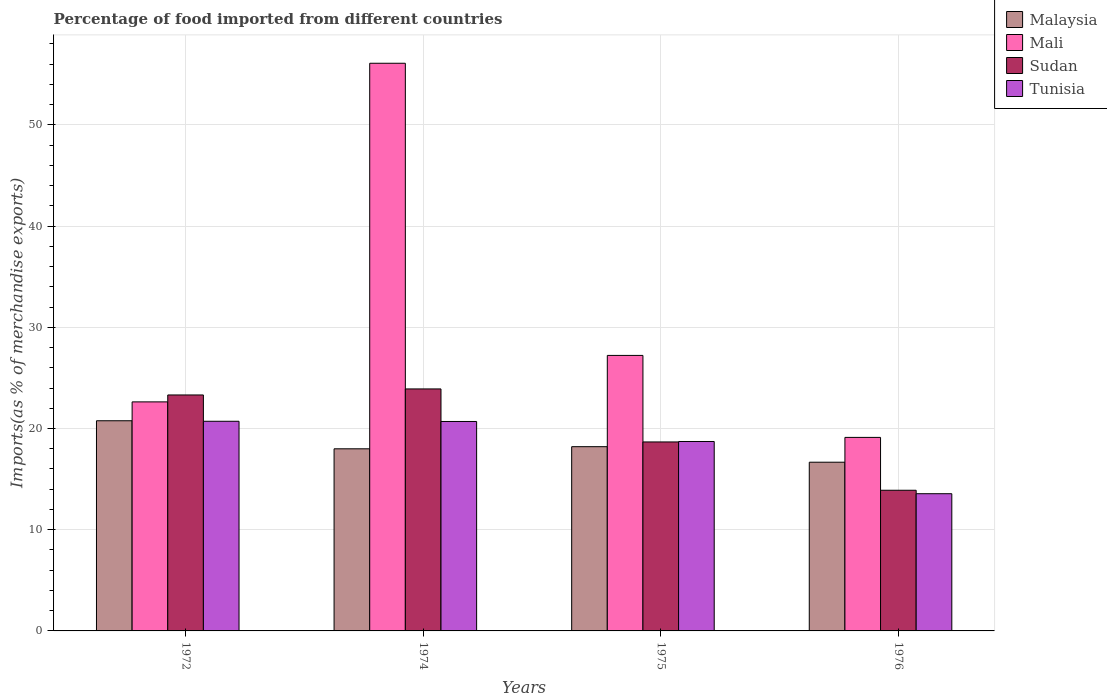How many groups of bars are there?
Provide a succinct answer. 4. Are the number of bars on each tick of the X-axis equal?
Ensure brevity in your answer.  Yes. How many bars are there on the 2nd tick from the right?
Ensure brevity in your answer.  4. In how many cases, is the number of bars for a given year not equal to the number of legend labels?
Your response must be concise. 0. What is the percentage of imports to different countries in Mali in 1974?
Give a very brief answer. 56.08. Across all years, what is the maximum percentage of imports to different countries in Tunisia?
Give a very brief answer. 20.71. Across all years, what is the minimum percentage of imports to different countries in Sudan?
Your response must be concise. 13.9. In which year was the percentage of imports to different countries in Malaysia maximum?
Your response must be concise. 1972. In which year was the percentage of imports to different countries in Mali minimum?
Offer a terse response. 1976. What is the total percentage of imports to different countries in Mali in the graph?
Provide a short and direct response. 125.05. What is the difference between the percentage of imports to different countries in Tunisia in 1972 and that in 1975?
Give a very brief answer. 2. What is the difference between the percentage of imports to different countries in Malaysia in 1975 and the percentage of imports to different countries in Sudan in 1972?
Offer a terse response. -5.11. What is the average percentage of imports to different countries in Sudan per year?
Provide a short and direct response. 19.95. In the year 1976, what is the difference between the percentage of imports to different countries in Tunisia and percentage of imports to different countries in Mali?
Provide a short and direct response. -5.56. In how many years, is the percentage of imports to different countries in Sudan greater than 26 %?
Your answer should be very brief. 0. What is the ratio of the percentage of imports to different countries in Tunisia in 1974 to that in 1975?
Ensure brevity in your answer.  1.11. Is the percentage of imports to different countries in Sudan in 1974 less than that in 1976?
Ensure brevity in your answer.  No. Is the difference between the percentage of imports to different countries in Tunisia in 1972 and 1974 greater than the difference between the percentage of imports to different countries in Mali in 1972 and 1974?
Ensure brevity in your answer.  Yes. What is the difference between the highest and the second highest percentage of imports to different countries in Malaysia?
Provide a succinct answer. 2.56. What is the difference between the highest and the lowest percentage of imports to different countries in Mali?
Your answer should be very brief. 36.96. Is the sum of the percentage of imports to different countries in Mali in 1972 and 1974 greater than the maximum percentage of imports to different countries in Malaysia across all years?
Provide a short and direct response. Yes. What does the 2nd bar from the left in 1975 represents?
Your answer should be compact. Mali. What does the 3rd bar from the right in 1976 represents?
Your answer should be very brief. Mali. Is it the case that in every year, the sum of the percentage of imports to different countries in Malaysia and percentage of imports to different countries in Tunisia is greater than the percentage of imports to different countries in Mali?
Make the answer very short. No. How many bars are there?
Provide a short and direct response. 16. How many years are there in the graph?
Offer a very short reply. 4. What is the difference between two consecutive major ticks on the Y-axis?
Give a very brief answer. 10. Are the values on the major ticks of Y-axis written in scientific E-notation?
Offer a terse response. No. Does the graph contain any zero values?
Your response must be concise. No. What is the title of the graph?
Your answer should be very brief. Percentage of food imported from different countries. What is the label or title of the X-axis?
Your response must be concise. Years. What is the label or title of the Y-axis?
Keep it short and to the point. Imports(as % of merchandise exports). What is the Imports(as % of merchandise exports) of Malaysia in 1972?
Keep it short and to the point. 20.76. What is the Imports(as % of merchandise exports) in Mali in 1972?
Give a very brief answer. 22.63. What is the Imports(as % of merchandise exports) of Sudan in 1972?
Offer a terse response. 23.31. What is the Imports(as % of merchandise exports) of Tunisia in 1972?
Your answer should be compact. 20.71. What is the Imports(as % of merchandise exports) in Malaysia in 1974?
Ensure brevity in your answer.  17.99. What is the Imports(as % of merchandise exports) in Mali in 1974?
Your response must be concise. 56.08. What is the Imports(as % of merchandise exports) in Sudan in 1974?
Give a very brief answer. 23.91. What is the Imports(as % of merchandise exports) of Tunisia in 1974?
Make the answer very short. 20.69. What is the Imports(as % of merchandise exports) of Malaysia in 1975?
Keep it short and to the point. 18.2. What is the Imports(as % of merchandise exports) in Mali in 1975?
Provide a succinct answer. 27.22. What is the Imports(as % of merchandise exports) of Sudan in 1975?
Offer a very short reply. 18.67. What is the Imports(as % of merchandise exports) in Tunisia in 1975?
Offer a terse response. 18.72. What is the Imports(as % of merchandise exports) of Malaysia in 1976?
Make the answer very short. 16.67. What is the Imports(as % of merchandise exports) of Mali in 1976?
Offer a terse response. 19.12. What is the Imports(as % of merchandise exports) of Sudan in 1976?
Offer a terse response. 13.9. What is the Imports(as % of merchandise exports) in Tunisia in 1976?
Provide a short and direct response. 13.56. Across all years, what is the maximum Imports(as % of merchandise exports) in Malaysia?
Offer a terse response. 20.76. Across all years, what is the maximum Imports(as % of merchandise exports) of Mali?
Your answer should be compact. 56.08. Across all years, what is the maximum Imports(as % of merchandise exports) of Sudan?
Give a very brief answer. 23.91. Across all years, what is the maximum Imports(as % of merchandise exports) of Tunisia?
Offer a very short reply. 20.71. Across all years, what is the minimum Imports(as % of merchandise exports) of Malaysia?
Keep it short and to the point. 16.67. Across all years, what is the minimum Imports(as % of merchandise exports) in Mali?
Offer a very short reply. 19.12. Across all years, what is the minimum Imports(as % of merchandise exports) of Sudan?
Offer a very short reply. 13.9. Across all years, what is the minimum Imports(as % of merchandise exports) in Tunisia?
Your answer should be very brief. 13.56. What is the total Imports(as % of merchandise exports) in Malaysia in the graph?
Ensure brevity in your answer.  73.63. What is the total Imports(as % of merchandise exports) in Mali in the graph?
Provide a short and direct response. 125.05. What is the total Imports(as % of merchandise exports) of Sudan in the graph?
Ensure brevity in your answer.  79.79. What is the total Imports(as % of merchandise exports) of Tunisia in the graph?
Provide a succinct answer. 73.68. What is the difference between the Imports(as % of merchandise exports) in Malaysia in 1972 and that in 1974?
Keep it short and to the point. 2.77. What is the difference between the Imports(as % of merchandise exports) of Mali in 1972 and that in 1974?
Offer a terse response. -33.46. What is the difference between the Imports(as % of merchandise exports) in Sudan in 1972 and that in 1974?
Your response must be concise. -0.6. What is the difference between the Imports(as % of merchandise exports) of Tunisia in 1972 and that in 1974?
Your answer should be very brief. 0.02. What is the difference between the Imports(as % of merchandise exports) of Malaysia in 1972 and that in 1975?
Make the answer very short. 2.56. What is the difference between the Imports(as % of merchandise exports) of Mali in 1972 and that in 1975?
Your answer should be very brief. -4.59. What is the difference between the Imports(as % of merchandise exports) in Sudan in 1972 and that in 1975?
Ensure brevity in your answer.  4.64. What is the difference between the Imports(as % of merchandise exports) in Tunisia in 1972 and that in 1975?
Your answer should be compact. 2. What is the difference between the Imports(as % of merchandise exports) of Malaysia in 1972 and that in 1976?
Keep it short and to the point. 4.1. What is the difference between the Imports(as % of merchandise exports) of Mali in 1972 and that in 1976?
Make the answer very short. 3.51. What is the difference between the Imports(as % of merchandise exports) of Sudan in 1972 and that in 1976?
Keep it short and to the point. 9.42. What is the difference between the Imports(as % of merchandise exports) in Tunisia in 1972 and that in 1976?
Give a very brief answer. 7.16. What is the difference between the Imports(as % of merchandise exports) in Malaysia in 1974 and that in 1975?
Make the answer very short. -0.21. What is the difference between the Imports(as % of merchandise exports) of Mali in 1974 and that in 1975?
Offer a terse response. 28.86. What is the difference between the Imports(as % of merchandise exports) in Sudan in 1974 and that in 1975?
Make the answer very short. 5.24. What is the difference between the Imports(as % of merchandise exports) in Tunisia in 1974 and that in 1975?
Your response must be concise. 1.98. What is the difference between the Imports(as % of merchandise exports) in Malaysia in 1974 and that in 1976?
Offer a terse response. 1.32. What is the difference between the Imports(as % of merchandise exports) in Mali in 1974 and that in 1976?
Give a very brief answer. 36.96. What is the difference between the Imports(as % of merchandise exports) in Sudan in 1974 and that in 1976?
Give a very brief answer. 10.01. What is the difference between the Imports(as % of merchandise exports) of Tunisia in 1974 and that in 1976?
Provide a succinct answer. 7.14. What is the difference between the Imports(as % of merchandise exports) in Malaysia in 1975 and that in 1976?
Give a very brief answer. 1.54. What is the difference between the Imports(as % of merchandise exports) in Mali in 1975 and that in 1976?
Offer a very short reply. 8.1. What is the difference between the Imports(as % of merchandise exports) of Sudan in 1975 and that in 1976?
Make the answer very short. 4.77. What is the difference between the Imports(as % of merchandise exports) in Tunisia in 1975 and that in 1976?
Your answer should be very brief. 5.16. What is the difference between the Imports(as % of merchandise exports) of Malaysia in 1972 and the Imports(as % of merchandise exports) of Mali in 1974?
Give a very brief answer. -35.32. What is the difference between the Imports(as % of merchandise exports) of Malaysia in 1972 and the Imports(as % of merchandise exports) of Sudan in 1974?
Your answer should be very brief. -3.15. What is the difference between the Imports(as % of merchandise exports) in Malaysia in 1972 and the Imports(as % of merchandise exports) in Tunisia in 1974?
Offer a very short reply. 0.07. What is the difference between the Imports(as % of merchandise exports) of Mali in 1972 and the Imports(as % of merchandise exports) of Sudan in 1974?
Your answer should be compact. -1.28. What is the difference between the Imports(as % of merchandise exports) in Mali in 1972 and the Imports(as % of merchandise exports) in Tunisia in 1974?
Provide a succinct answer. 1.93. What is the difference between the Imports(as % of merchandise exports) of Sudan in 1972 and the Imports(as % of merchandise exports) of Tunisia in 1974?
Your answer should be compact. 2.62. What is the difference between the Imports(as % of merchandise exports) in Malaysia in 1972 and the Imports(as % of merchandise exports) in Mali in 1975?
Your answer should be compact. -6.46. What is the difference between the Imports(as % of merchandise exports) in Malaysia in 1972 and the Imports(as % of merchandise exports) in Sudan in 1975?
Your response must be concise. 2.09. What is the difference between the Imports(as % of merchandise exports) of Malaysia in 1972 and the Imports(as % of merchandise exports) of Tunisia in 1975?
Provide a short and direct response. 2.05. What is the difference between the Imports(as % of merchandise exports) of Mali in 1972 and the Imports(as % of merchandise exports) of Sudan in 1975?
Offer a very short reply. 3.96. What is the difference between the Imports(as % of merchandise exports) in Mali in 1972 and the Imports(as % of merchandise exports) in Tunisia in 1975?
Your answer should be very brief. 3.91. What is the difference between the Imports(as % of merchandise exports) of Sudan in 1972 and the Imports(as % of merchandise exports) of Tunisia in 1975?
Ensure brevity in your answer.  4.6. What is the difference between the Imports(as % of merchandise exports) of Malaysia in 1972 and the Imports(as % of merchandise exports) of Mali in 1976?
Your answer should be very brief. 1.64. What is the difference between the Imports(as % of merchandise exports) of Malaysia in 1972 and the Imports(as % of merchandise exports) of Sudan in 1976?
Your response must be concise. 6.87. What is the difference between the Imports(as % of merchandise exports) in Malaysia in 1972 and the Imports(as % of merchandise exports) in Tunisia in 1976?
Your answer should be very brief. 7.21. What is the difference between the Imports(as % of merchandise exports) in Mali in 1972 and the Imports(as % of merchandise exports) in Sudan in 1976?
Your answer should be very brief. 8.73. What is the difference between the Imports(as % of merchandise exports) of Mali in 1972 and the Imports(as % of merchandise exports) of Tunisia in 1976?
Ensure brevity in your answer.  9.07. What is the difference between the Imports(as % of merchandise exports) of Sudan in 1972 and the Imports(as % of merchandise exports) of Tunisia in 1976?
Provide a short and direct response. 9.76. What is the difference between the Imports(as % of merchandise exports) of Malaysia in 1974 and the Imports(as % of merchandise exports) of Mali in 1975?
Your answer should be compact. -9.23. What is the difference between the Imports(as % of merchandise exports) of Malaysia in 1974 and the Imports(as % of merchandise exports) of Sudan in 1975?
Ensure brevity in your answer.  -0.68. What is the difference between the Imports(as % of merchandise exports) of Malaysia in 1974 and the Imports(as % of merchandise exports) of Tunisia in 1975?
Provide a succinct answer. -0.72. What is the difference between the Imports(as % of merchandise exports) of Mali in 1974 and the Imports(as % of merchandise exports) of Sudan in 1975?
Make the answer very short. 37.41. What is the difference between the Imports(as % of merchandise exports) in Mali in 1974 and the Imports(as % of merchandise exports) in Tunisia in 1975?
Provide a short and direct response. 37.37. What is the difference between the Imports(as % of merchandise exports) of Sudan in 1974 and the Imports(as % of merchandise exports) of Tunisia in 1975?
Offer a terse response. 5.19. What is the difference between the Imports(as % of merchandise exports) of Malaysia in 1974 and the Imports(as % of merchandise exports) of Mali in 1976?
Offer a very short reply. -1.13. What is the difference between the Imports(as % of merchandise exports) in Malaysia in 1974 and the Imports(as % of merchandise exports) in Sudan in 1976?
Provide a succinct answer. 4.1. What is the difference between the Imports(as % of merchandise exports) of Malaysia in 1974 and the Imports(as % of merchandise exports) of Tunisia in 1976?
Give a very brief answer. 4.44. What is the difference between the Imports(as % of merchandise exports) of Mali in 1974 and the Imports(as % of merchandise exports) of Sudan in 1976?
Provide a succinct answer. 42.19. What is the difference between the Imports(as % of merchandise exports) in Mali in 1974 and the Imports(as % of merchandise exports) in Tunisia in 1976?
Give a very brief answer. 42.53. What is the difference between the Imports(as % of merchandise exports) of Sudan in 1974 and the Imports(as % of merchandise exports) of Tunisia in 1976?
Your answer should be compact. 10.35. What is the difference between the Imports(as % of merchandise exports) of Malaysia in 1975 and the Imports(as % of merchandise exports) of Mali in 1976?
Offer a terse response. -0.92. What is the difference between the Imports(as % of merchandise exports) of Malaysia in 1975 and the Imports(as % of merchandise exports) of Sudan in 1976?
Keep it short and to the point. 4.31. What is the difference between the Imports(as % of merchandise exports) in Malaysia in 1975 and the Imports(as % of merchandise exports) in Tunisia in 1976?
Provide a short and direct response. 4.65. What is the difference between the Imports(as % of merchandise exports) of Mali in 1975 and the Imports(as % of merchandise exports) of Sudan in 1976?
Offer a very short reply. 13.32. What is the difference between the Imports(as % of merchandise exports) in Mali in 1975 and the Imports(as % of merchandise exports) in Tunisia in 1976?
Provide a short and direct response. 13.66. What is the difference between the Imports(as % of merchandise exports) in Sudan in 1975 and the Imports(as % of merchandise exports) in Tunisia in 1976?
Provide a succinct answer. 5.11. What is the average Imports(as % of merchandise exports) of Malaysia per year?
Give a very brief answer. 18.41. What is the average Imports(as % of merchandise exports) in Mali per year?
Offer a terse response. 31.26. What is the average Imports(as % of merchandise exports) in Sudan per year?
Your answer should be very brief. 19.95. What is the average Imports(as % of merchandise exports) of Tunisia per year?
Provide a short and direct response. 18.42. In the year 1972, what is the difference between the Imports(as % of merchandise exports) of Malaysia and Imports(as % of merchandise exports) of Mali?
Offer a very short reply. -1.86. In the year 1972, what is the difference between the Imports(as % of merchandise exports) of Malaysia and Imports(as % of merchandise exports) of Sudan?
Your answer should be compact. -2.55. In the year 1972, what is the difference between the Imports(as % of merchandise exports) in Malaysia and Imports(as % of merchandise exports) in Tunisia?
Your answer should be compact. 0.05. In the year 1972, what is the difference between the Imports(as % of merchandise exports) in Mali and Imports(as % of merchandise exports) in Sudan?
Offer a terse response. -0.68. In the year 1972, what is the difference between the Imports(as % of merchandise exports) in Mali and Imports(as % of merchandise exports) in Tunisia?
Offer a very short reply. 1.91. In the year 1972, what is the difference between the Imports(as % of merchandise exports) of Sudan and Imports(as % of merchandise exports) of Tunisia?
Keep it short and to the point. 2.6. In the year 1974, what is the difference between the Imports(as % of merchandise exports) of Malaysia and Imports(as % of merchandise exports) of Mali?
Offer a terse response. -38.09. In the year 1974, what is the difference between the Imports(as % of merchandise exports) of Malaysia and Imports(as % of merchandise exports) of Sudan?
Give a very brief answer. -5.92. In the year 1974, what is the difference between the Imports(as % of merchandise exports) in Malaysia and Imports(as % of merchandise exports) in Tunisia?
Your answer should be compact. -2.7. In the year 1974, what is the difference between the Imports(as % of merchandise exports) of Mali and Imports(as % of merchandise exports) of Sudan?
Make the answer very short. 32.18. In the year 1974, what is the difference between the Imports(as % of merchandise exports) in Mali and Imports(as % of merchandise exports) in Tunisia?
Ensure brevity in your answer.  35.39. In the year 1974, what is the difference between the Imports(as % of merchandise exports) of Sudan and Imports(as % of merchandise exports) of Tunisia?
Keep it short and to the point. 3.22. In the year 1975, what is the difference between the Imports(as % of merchandise exports) in Malaysia and Imports(as % of merchandise exports) in Mali?
Ensure brevity in your answer.  -9.02. In the year 1975, what is the difference between the Imports(as % of merchandise exports) of Malaysia and Imports(as % of merchandise exports) of Sudan?
Offer a very short reply. -0.47. In the year 1975, what is the difference between the Imports(as % of merchandise exports) of Malaysia and Imports(as % of merchandise exports) of Tunisia?
Offer a terse response. -0.51. In the year 1975, what is the difference between the Imports(as % of merchandise exports) in Mali and Imports(as % of merchandise exports) in Sudan?
Keep it short and to the point. 8.55. In the year 1975, what is the difference between the Imports(as % of merchandise exports) in Mali and Imports(as % of merchandise exports) in Tunisia?
Give a very brief answer. 8.5. In the year 1975, what is the difference between the Imports(as % of merchandise exports) in Sudan and Imports(as % of merchandise exports) in Tunisia?
Give a very brief answer. -0.05. In the year 1976, what is the difference between the Imports(as % of merchandise exports) in Malaysia and Imports(as % of merchandise exports) in Mali?
Give a very brief answer. -2.45. In the year 1976, what is the difference between the Imports(as % of merchandise exports) in Malaysia and Imports(as % of merchandise exports) in Sudan?
Give a very brief answer. 2.77. In the year 1976, what is the difference between the Imports(as % of merchandise exports) in Malaysia and Imports(as % of merchandise exports) in Tunisia?
Give a very brief answer. 3.11. In the year 1976, what is the difference between the Imports(as % of merchandise exports) of Mali and Imports(as % of merchandise exports) of Sudan?
Provide a short and direct response. 5.22. In the year 1976, what is the difference between the Imports(as % of merchandise exports) in Mali and Imports(as % of merchandise exports) in Tunisia?
Make the answer very short. 5.56. In the year 1976, what is the difference between the Imports(as % of merchandise exports) of Sudan and Imports(as % of merchandise exports) of Tunisia?
Give a very brief answer. 0.34. What is the ratio of the Imports(as % of merchandise exports) in Malaysia in 1972 to that in 1974?
Provide a succinct answer. 1.15. What is the ratio of the Imports(as % of merchandise exports) of Mali in 1972 to that in 1974?
Make the answer very short. 0.4. What is the ratio of the Imports(as % of merchandise exports) in Sudan in 1972 to that in 1974?
Your response must be concise. 0.98. What is the ratio of the Imports(as % of merchandise exports) of Malaysia in 1972 to that in 1975?
Offer a very short reply. 1.14. What is the ratio of the Imports(as % of merchandise exports) of Mali in 1972 to that in 1975?
Give a very brief answer. 0.83. What is the ratio of the Imports(as % of merchandise exports) of Sudan in 1972 to that in 1975?
Provide a short and direct response. 1.25. What is the ratio of the Imports(as % of merchandise exports) of Tunisia in 1972 to that in 1975?
Offer a very short reply. 1.11. What is the ratio of the Imports(as % of merchandise exports) of Malaysia in 1972 to that in 1976?
Provide a short and direct response. 1.25. What is the ratio of the Imports(as % of merchandise exports) of Mali in 1972 to that in 1976?
Your response must be concise. 1.18. What is the ratio of the Imports(as % of merchandise exports) of Sudan in 1972 to that in 1976?
Ensure brevity in your answer.  1.68. What is the ratio of the Imports(as % of merchandise exports) of Tunisia in 1972 to that in 1976?
Provide a succinct answer. 1.53. What is the ratio of the Imports(as % of merchandise exports) of Malaysia in 1974 to that in 1975?
Provide a succinct answer. 0.99. What is the ratio of the Imports(as % of merchandise exports) of Mali in 1974 to that in 1975?
Offer a terse response. 2.06. What is the ratio of the Imports(as % of merchandise exports) of Sudan in 1974 to that in 1975?
Offer a terse response. 1.28. What is the ratio of the Imports(as % of merchandise exports) in Tunisia in 1974 to that in 1975?
Your answer should be compact. 1.11. What is the ratio of the Imports(as % of merchandise exports) of Malaysia in 1974 to that in 1976?
Your answer should be very brief. 1.08. What is the ratio of the Imports(as % of merchandise exports) in Mali in 1974 to that in 1976?
Your answer should be very brief. 2.93. What is the ratio of the Imports(as % of merchandise exports) of Sudan in 1974 to that in 1976?
Ensure brevity in your answer.  1.72. What is the ratio of the Imports(as % of merchandise exports) of Tunisia in 1974 to that in 1976?
Make the answer very short. 1.53. What is the ratio of the Imports(as % of merchandise exports) in Malaysia in 1975 to that in 1976?
Provide a short and direct response. 1.09. What is the ratio of the Imports(as % of merchandise exports) in Mali in 1975 to that in 1976?
Your answer should be very brief. 1.42. What is the ratio of the Imports(as % of merchandise exports) in Sudan in 1975 to that in 1976?
Your response must be concise. 1.34. What is the ratio of the Imports(as % of merchandise exports) of Tunisia in 1975 to that in 1976?
Your response must be concise. 1.38. What is the difference between the highest and the second highest Imports(as % of merchandise exports) of Malaysia?
Give a very brief answer. 2.56. What is the difference between the highest and the second highest Imports(as % of merchandise exports) in Mali?
Provide a short and direct response. 28.86. What is the difference between the highest and the second highest Imports(as % of merchandise exports) of Sudan?
Give a very brief answer. 0.6. What is the difference between the highest and the second highest Imports(as % of merchandise exports) of Tunisia?
Your answer should be very brief. 0.02. What is the difference between the highest and the lowest Imports(as % of merchandise exports) of Malaysia?
Offer a terse response. 4.1. What is the difference between the highest and the lowest Imports(as % of merchandise exports) of Mali?
Provide a succinct answer. 36.96. What is the difference between the highest and the lowest Imports(as % of merchandise exports) of Sudan?
Give a very brief answer. 10.01. What is the difference between the highest and the lowest Imports(as % of merchandise exports) in Tunisia?
Offer a terse response. 7.16. 